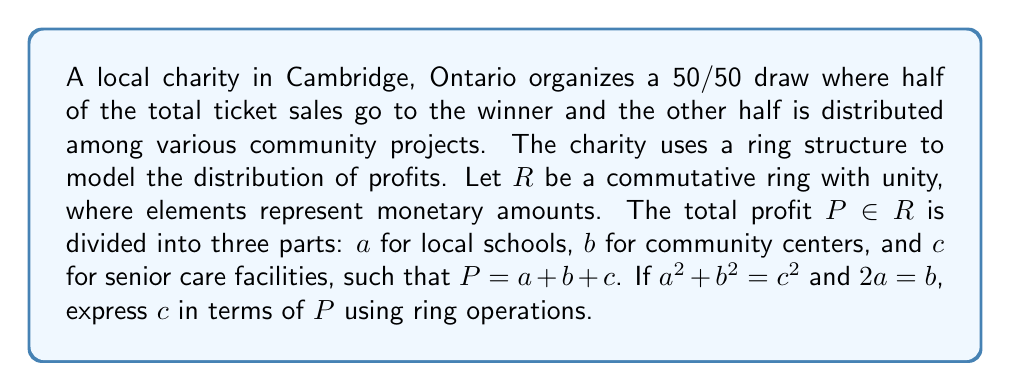What is the answer to this math problem? Let's approach this step-by-step using ring theory:

1) We're given that $P = a + b + c$ in the ring $R$.

2) We're also given two conditions:
   $a^2 + b^2 = c^2$ and $2a = b$

3) Let's start by substituting $b = 2a$ into the first condition:
   $a^2 + (2a)^2 = c^2$
   $a^2 + 4a^2 = c^2$
   $5a^2 = c^2$

4) Now, let's express $b$ and $c$ in terms of $a$:
   $b = 2a$
   $c = \sqrt{5}a$ (note: we assume $\sqrt{5}$ exists in $R$)

5) Substituting these into the original equation $P = a + b + c$:
   $P = a + 2a + \sqrt{5}a$
   $P = (3 + \sqrt{5})a$

6) To isolate $a$, we multiply both sides by the multiplicative inverse of $(3 + \sqrt{5})$:
   $a = P \cdot (3 + \sqrt{5})^{-1}$

7) Now we can express $c$ in terms of $P$:
   $c = \sqrt{5}a = \sqrt{5} \cdot P \cdot (3 + \sqrt{5})^{-1}$

8) Simplifying:
   $c = P \cdot \frac{\sqrt{5}}{3 + \sqrt{5}}$

   $c = P \cdot \frac{\sqrt{5}(3 - \sqrt{5})}{(3 + \sqrt{5})(3 - \sqrt{5})}$

   $c = P \cdot \frac{3\sqrt{5} - 5}{9 - 5}$

   $c = P \cdot \frac{3\sqrt{5} - 5}{4}$

Therefore, in the ring $R$, $c = P \cdot \frac{3\sqrt{5} - 5}{4}$.
Answer: $c = P \cdot \frac{3\sqrt{5} - 5}{4}$ 